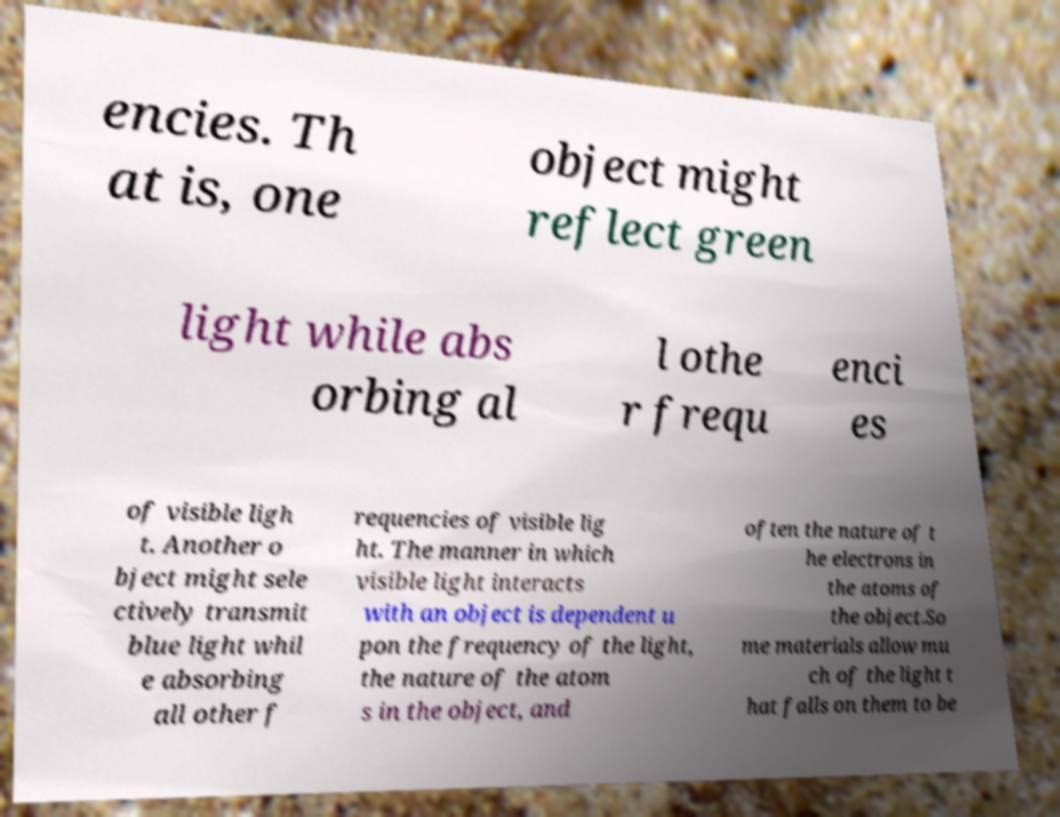Could you extract and type out the text from this image? encies. Th at is, one object might reflect green light while abs orbing al l othe r frequ enci es of visible ligh t. Another o bject might sele ctively transmit blue light whil e absorbing all other f requencies of visible lig ht. The manner in which visible light interacts with an object is dependent u pon the frequency of the light, the nature of the atom s in the object, and often the nature of t he electrons in the atoms of the object.So me materials allow mu ch of the light t hat falls on them to be 